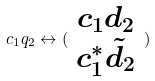<formula> <loc_0><loc_0><loc_500><loc_500>c _ { 1 } q _ { 2 } \leftrightarrow ( \begin{array} { c } c _ { 1 } d _ { 2 } \\ c _ { 1 } ^ { * } \tilde { d } _ { 2 } \end{array} )</formula> 